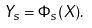<formula> <loc_0><loc_0><loc_500><loc_500>Y _ { s } = \Phi _ { s } ( X ) .</formula> 